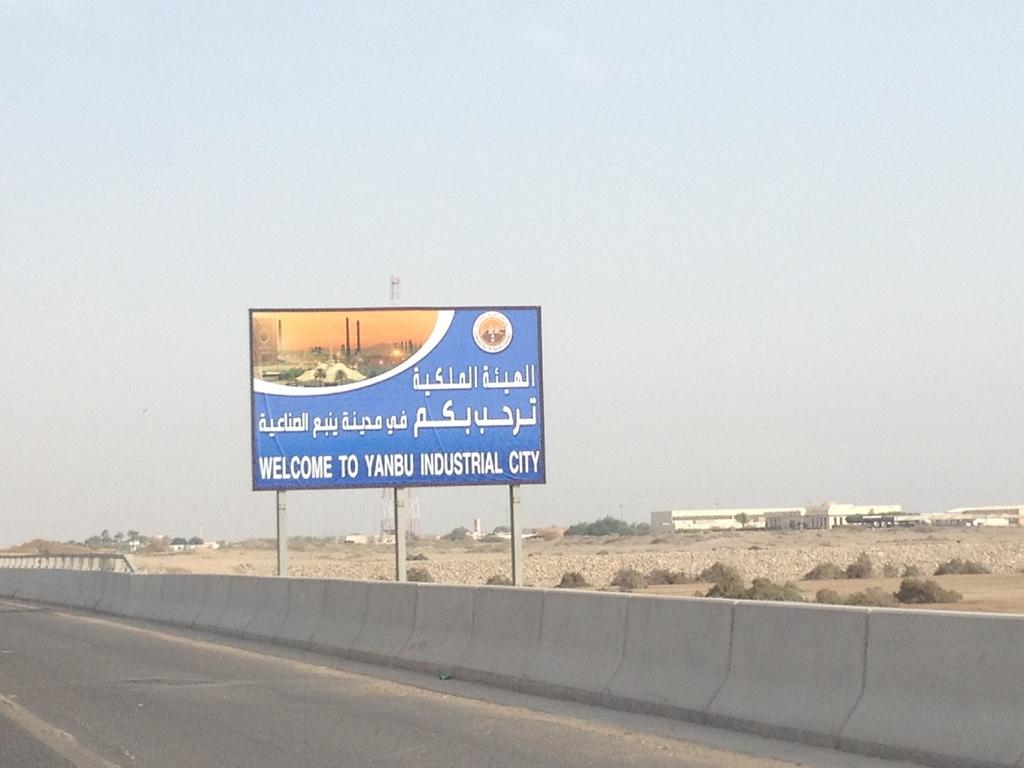<image>
Present a compact description of the photo's key features. A sign is welcoming people to Yanbu Industrial City. 